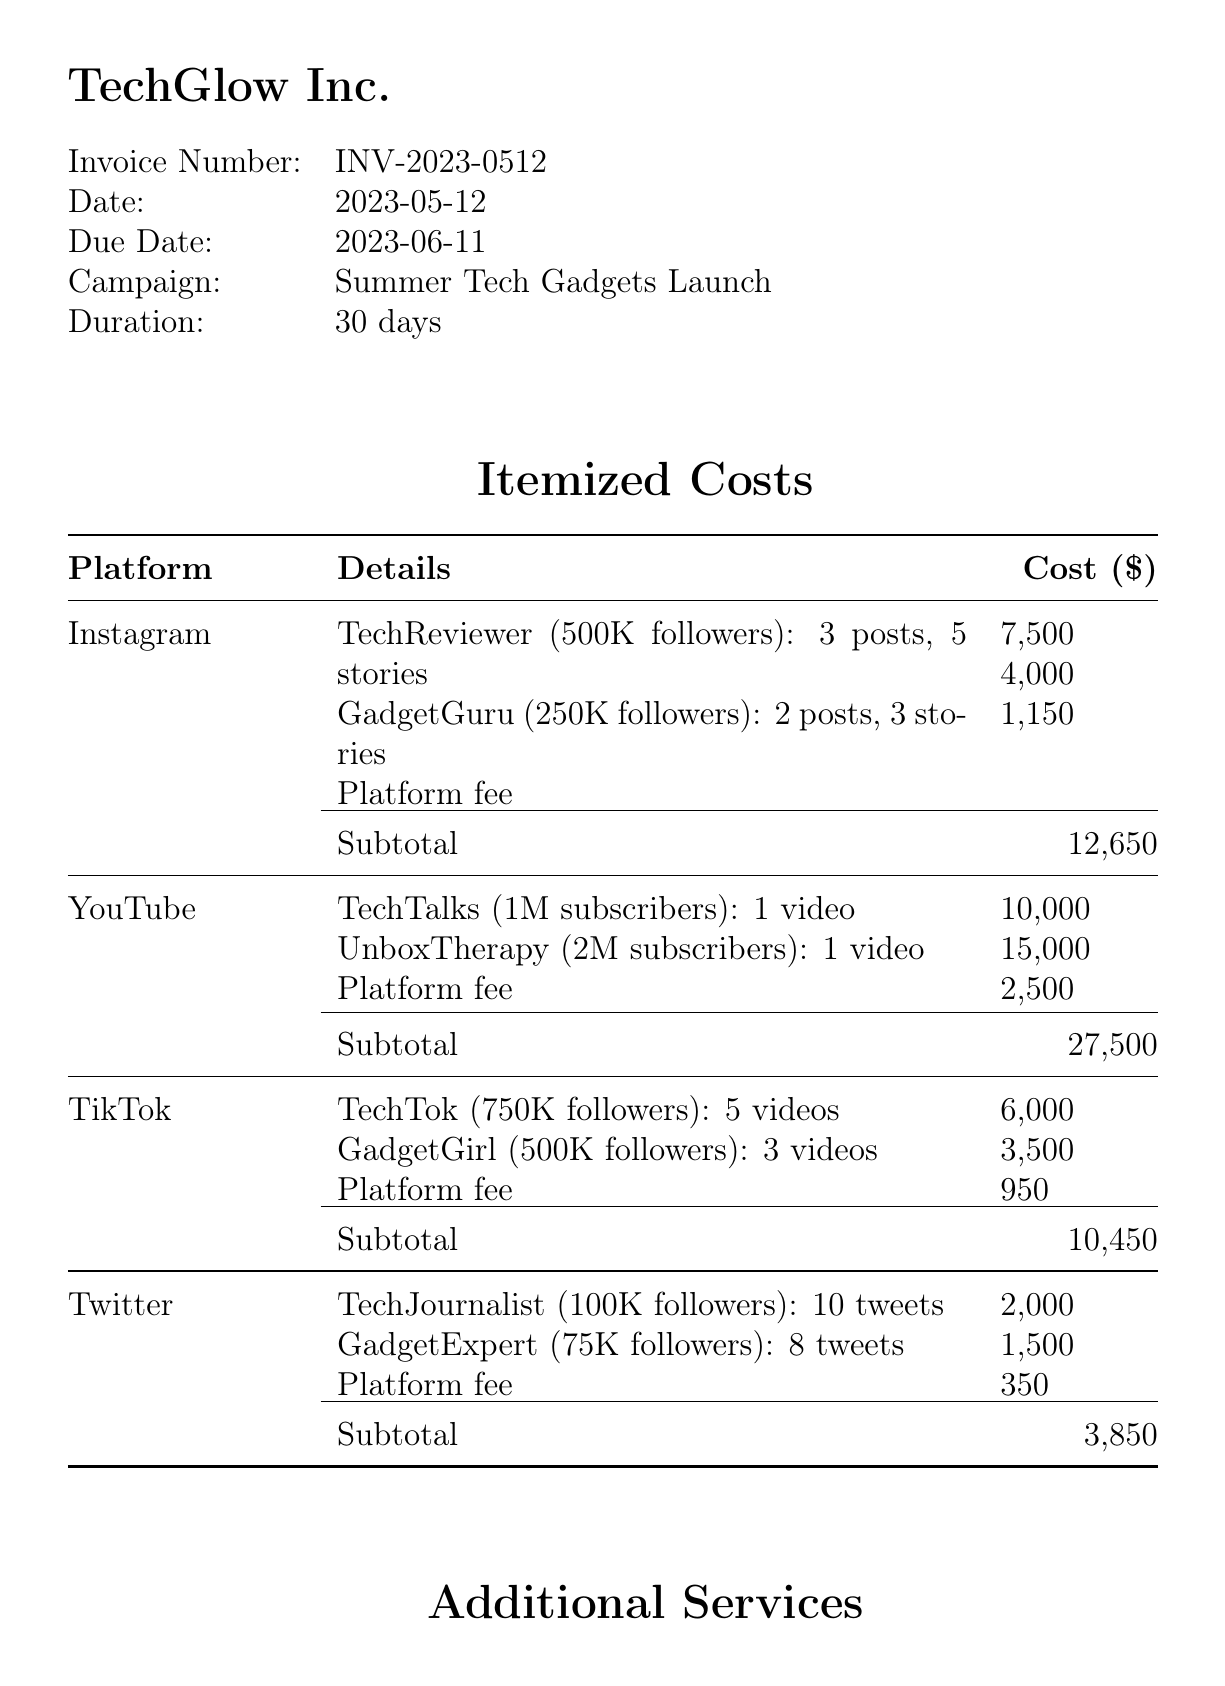what is the invoice number? The invoice number is listed at the top of the document.
Answer: INV-2023-0512 what is the due date for the invoice? The due date is provided under the invoice information section.
Answer: 2023-06-11 how many influencers are listed for the Instagram platform? The document itemizes influencers under each platform, specifically noting the number for Instagram.
Answer: 2 what is the subtotal for TikTok? The subtotal is given under the TikTok itemization.
Answer: 10,450 what is the total amount due on the invoice? The total amount is summarized at the bottom of the invoice.
Answer: 66,366 what service provides assistance in creating brand-aligned content? The additional services section describes various service offerings.
Answer: Content Creation Support how much is the tax on the subtotal? The tax amount is calculated based on the subtotal and is provided in the document.
Answer: 4,916 which platform has the highest subtotal cost? By comparing the subtotals listed for each platform, we can determine which one is highest.
Answer: YouTube what is the payment term specified in the document? The payment terms are clearly stated at the bottom of the invoice.
Answer: Net 30 